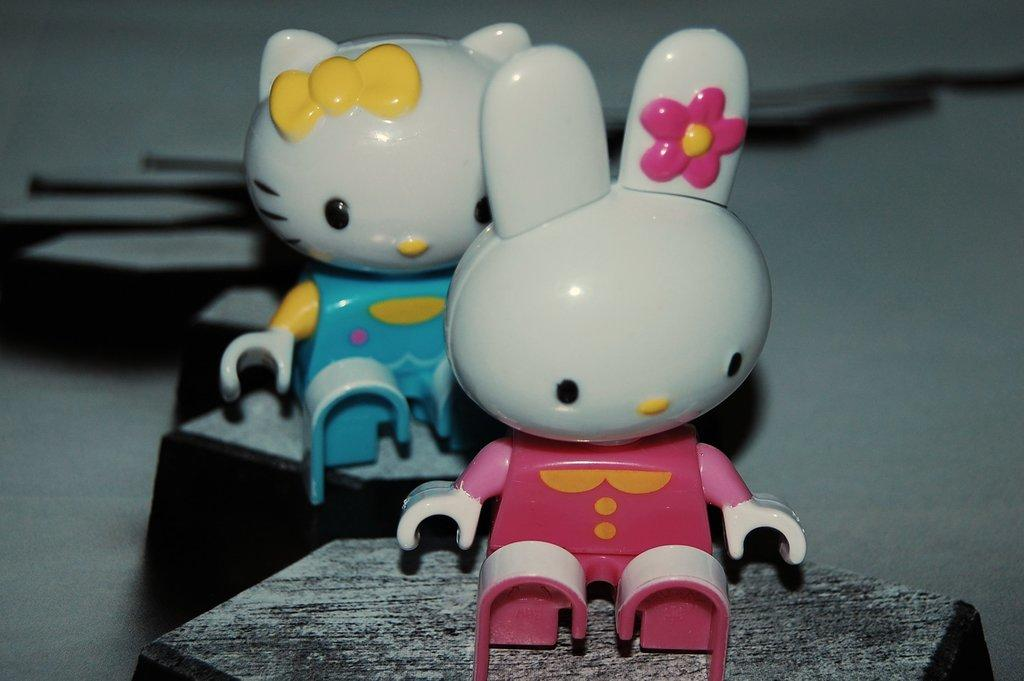What can be seen in the image? There are two toys in the image. What are the toys doing in the image? The toys are sitting on objects. Can you describe the background of the image? There are few objects in the background of the image. How many cats can be seen playing with the toys in the image? There are no cats present in the image, and therefore no such activity can be observed. 